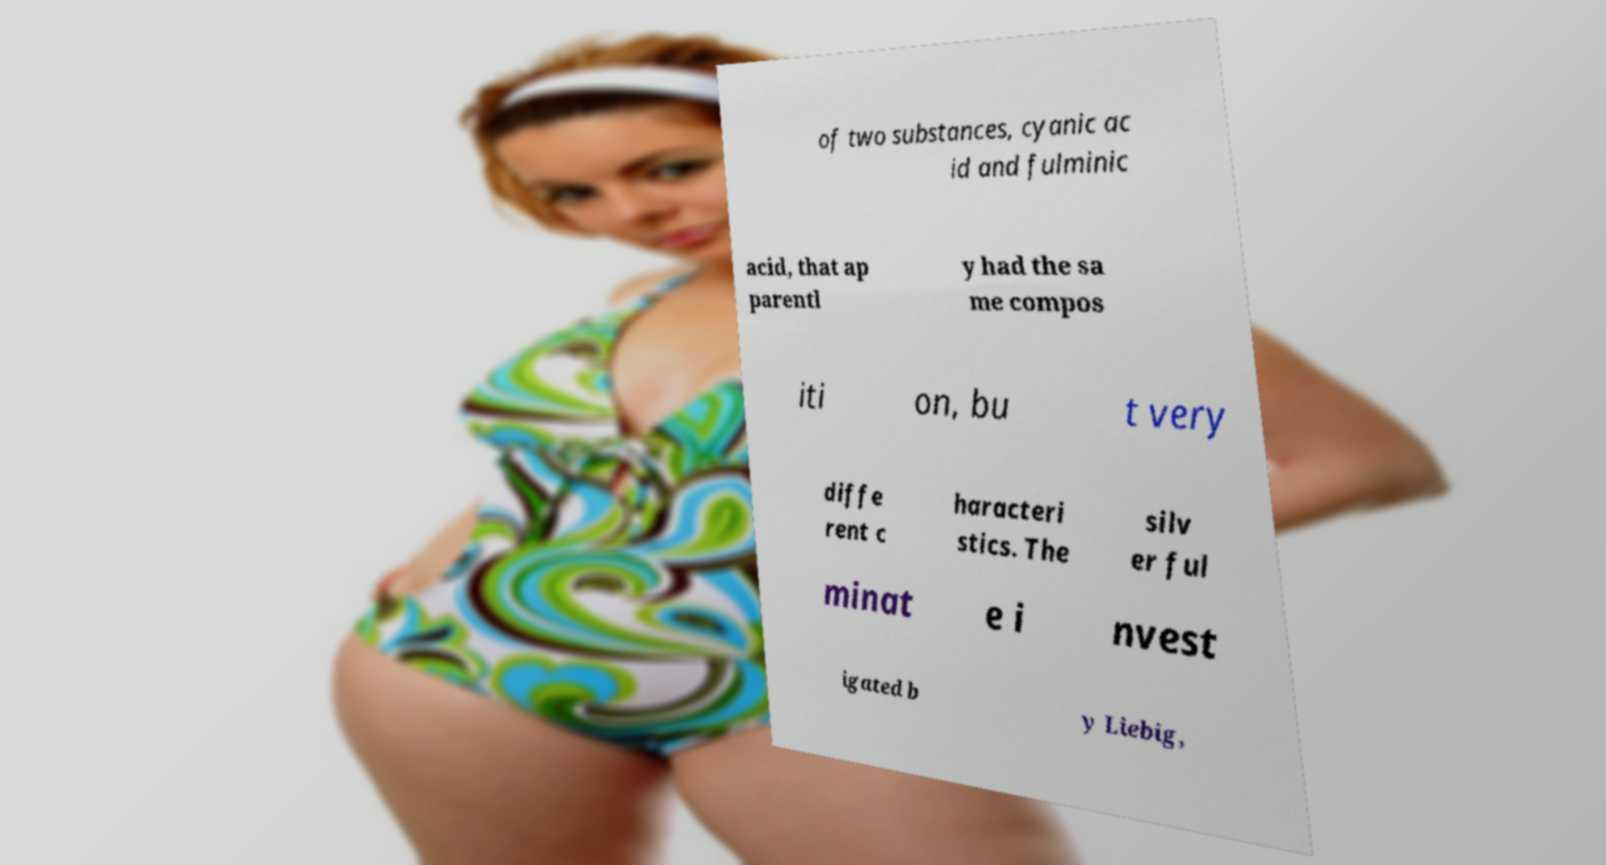Can you accurately transcribe the text from the provided image for me? of two substances, cyanic ac id and fulminic acid, that ap parentl y had the sa me compos iti on, bu t very diffe rent c haracteri stics. The silv er ful minat e i nvest igated b y Liebig, 